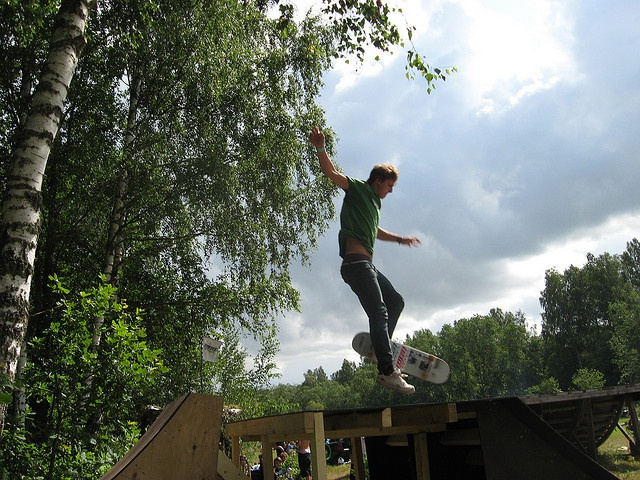Describe the objects in this image and their specific colors. I can see people in black, maroon, gray, and darkgray tones, skateboard in black, gray, and maroon tones, people in black, maroon, and gray tones, people in black, maroon, and gray tones, and people in black, maroon, olive, and gray tones in this image. 